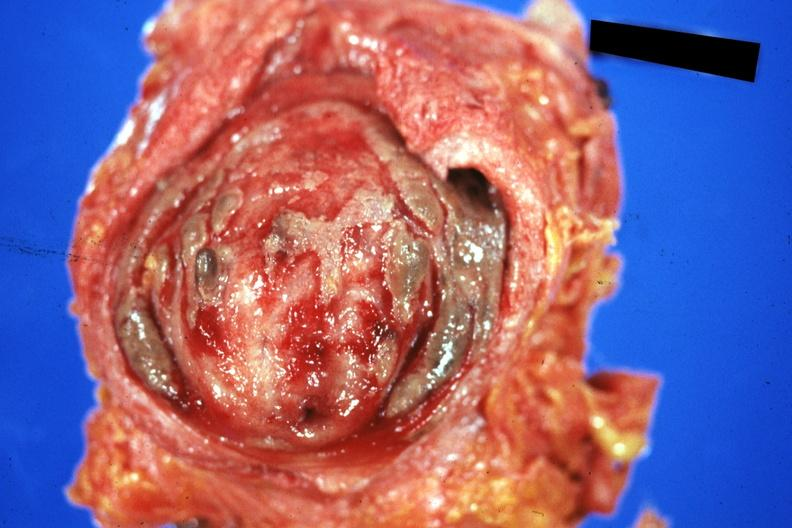what does this image show?
Answer the question using a single word or phrase. Mucosal surface quite good 